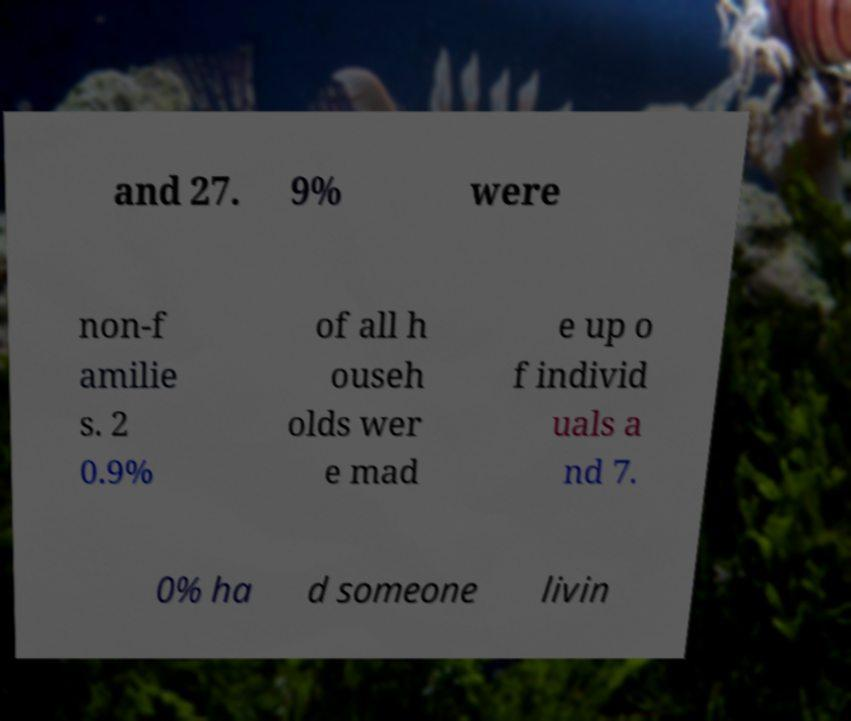There's text embedded in this image that I need extracted. Can you transcribe it verbatim? and 27. 9% were non-f amilie s. 2 0.9% of all h ouseh olds wer e mad e up o f individ uals a nd 7. 0% ha d someone livin 